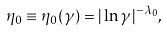<formula> <loc_0><loc_0><loc_500><loc_500>\eta _ { 0 } \equiv \eta _ { 0 } ( \gamma ) = | \ln \gamma | ^ { - \lambda _ { 0 } } ,</formula> 